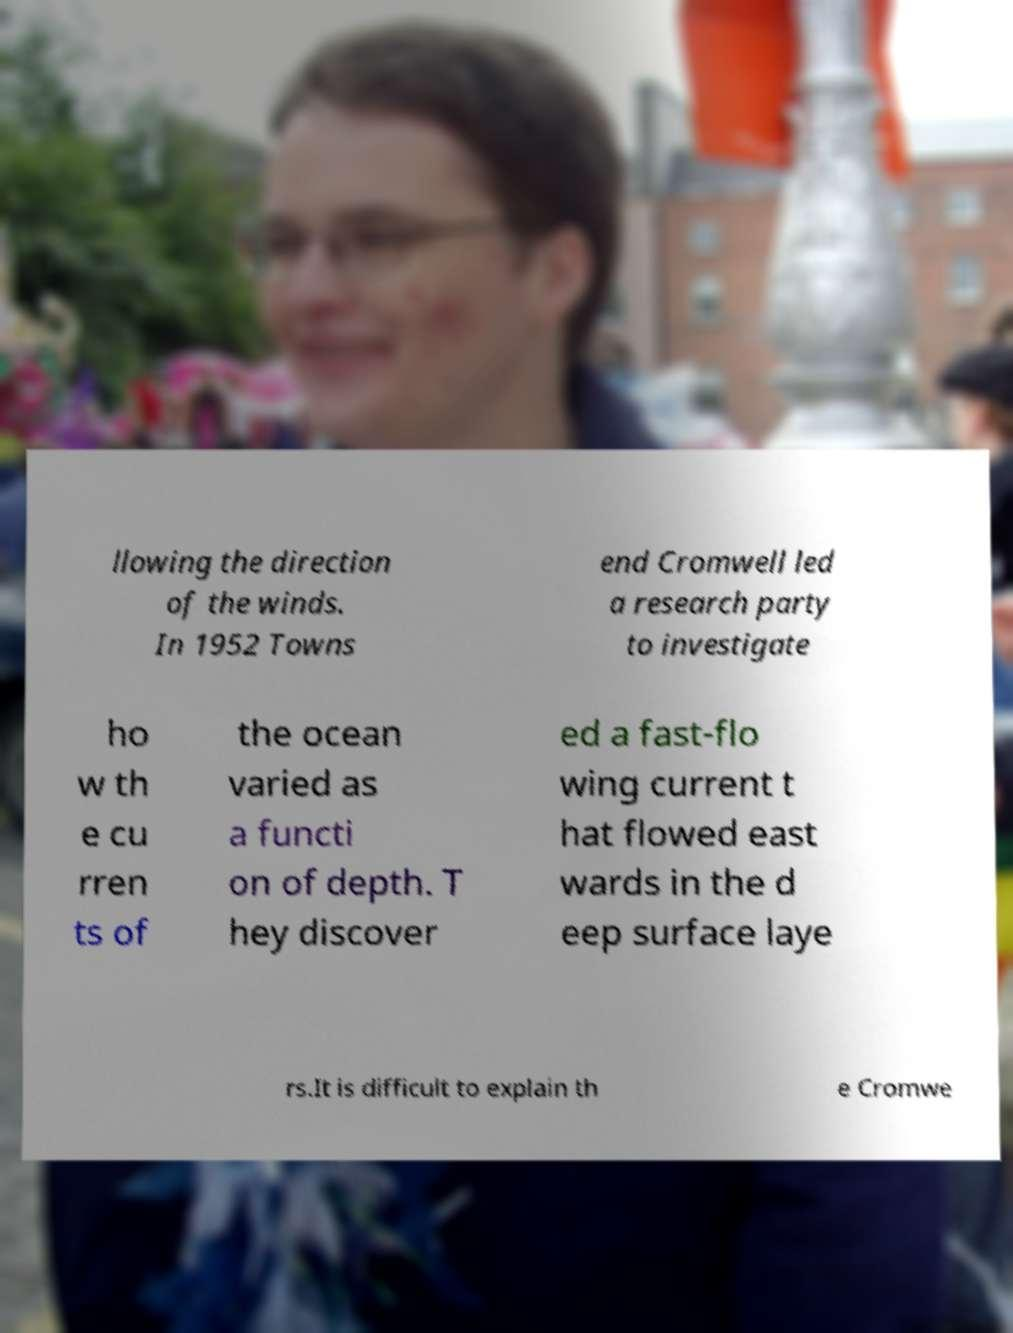Could you assist in decoding the text presented in this image and type it out clearly? llowing the direction of the winds. In 1952 Towns end Cromwell led a research party to investigate ho w th e cu rren ts of the ocean varied as a functi on of depth. T hey discover ed a fast-flo wing current t hat flowed east wards in the d eep surface laye rs.It is difficult to explain th e Cromwe 